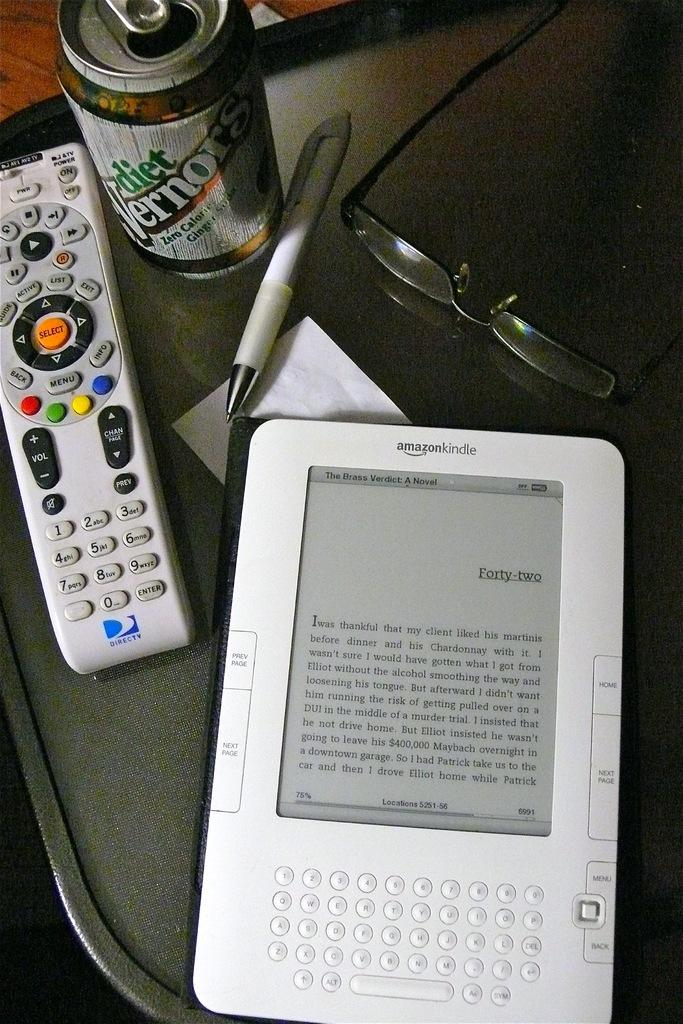Provide a one-sentence caption for the provided image. A can of Diet Vernon next to a remote control and a Kindle. 